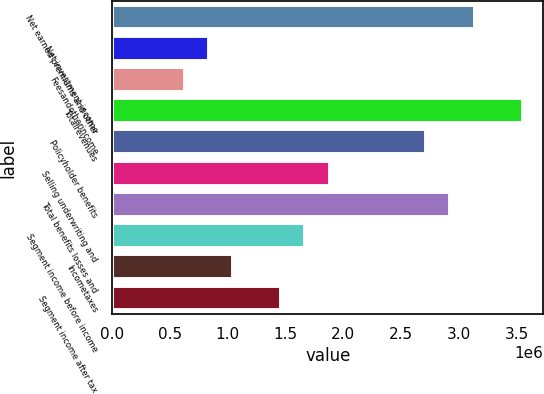Convert chart. <chart><loc_0><loc_0><loc_500><loc_500><bar_chart><fcel>Net earned premiums and other<fcel>Net investment income<fcel>Feesandotherincome<fcel>Totalrevenues<fcel>Policyholder benefits<fcel>Selling underwriting and<fcel>Total benefits losses and<fcel>Segment income before income<fcel>Incometaxes<fcel>Segment income after tax<nl><fcel>3.13639e+06<fcel>836391<fcel>627300<fcel>3.55457e+06<fcel>2.7182e+06<fcel>1.88184e+06<fcel>2.92729e+06<fcel>1.67275e+06<fcel>1.04548e+06<fcel>1.46366e+06<nl></chart> 